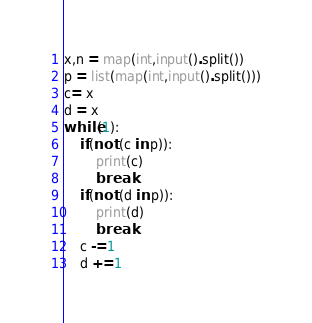Convert code to text. <code><loc_0><loc_0><loc_500><loc_500><_Python_>x,n = map(int,input().split())
p = list(map(int,input().split()))
c= x
d = x
while(1):
    if(not (c in p)):
        print(c)
        break
    if(not (d in p)):
        print(d)
        break
    c -=1
    d +=1</code> 